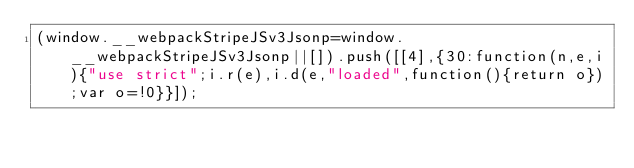<code> <loc_0><loc_0><loc_500><loc_500><_JavaScript_>(window.__webpackStripeJSv3Jsonp=window.__webpackStripeJSv3Jsonp||[]).push([[4],{30:function(n,e,i){"use strict";i.r(e),i.d(e,"loaded",function(){return o});var o=!0}}]);</code> 